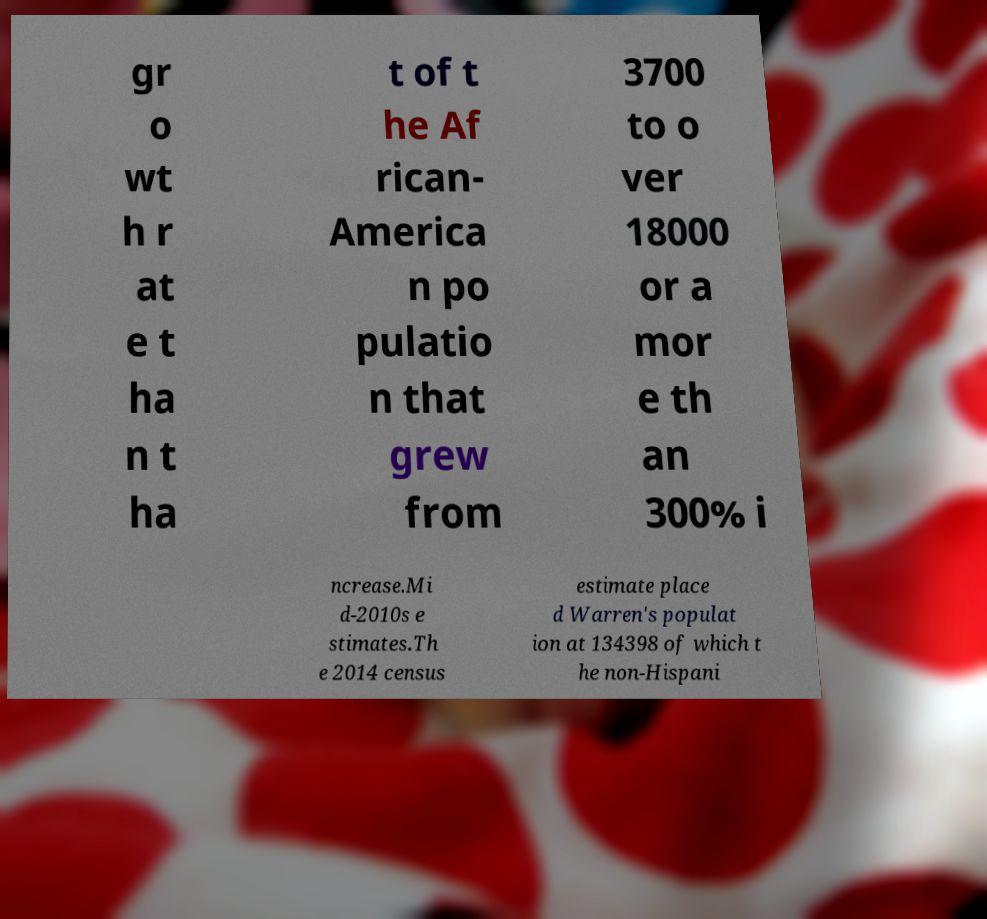For documentation purposes, I need the text within this image transcribed. Could you provide that? gr o wt h r at e t ha n t ha t of t he Af rican- America n po pulatio n that grew from 3700 to o ver 18000 or a mor e th an 300% i ncrease.Mi d-2010s e stimates.Th e 2014 census estimate place d Warren's populat ion at 134398 of which t he non-Hispani 